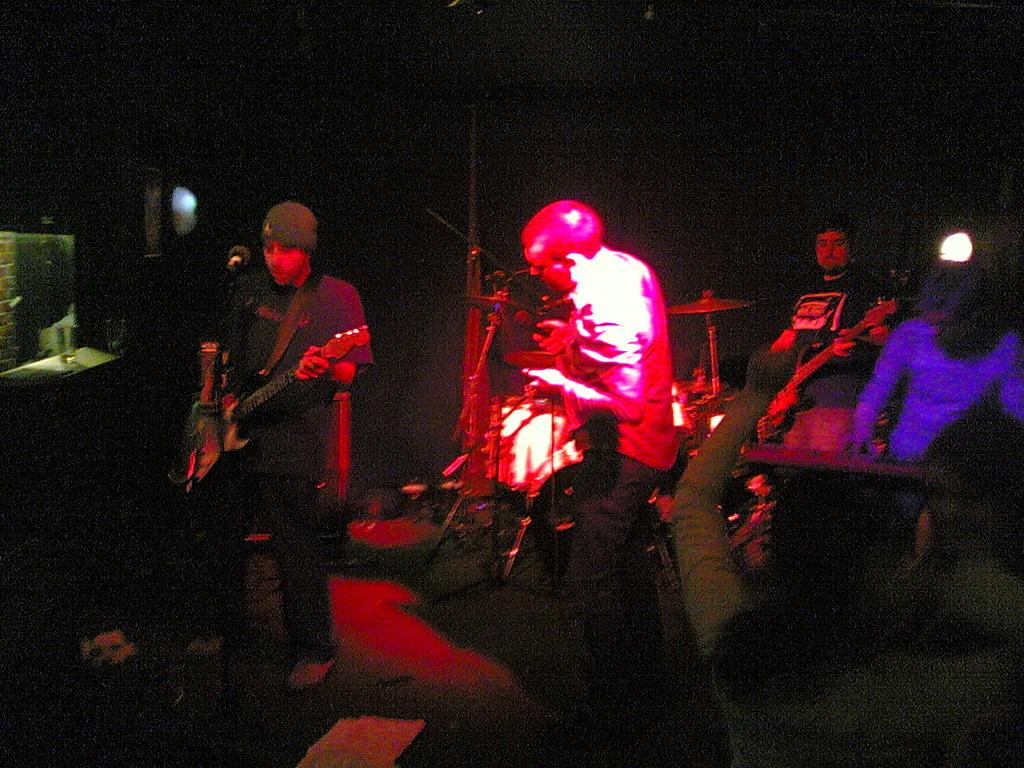How many people are in the image? There are people in the image, but the exact number is not specified. What are the people doing in the image? The people are standing and playing musical instruments. Can you describe the actions of the people in the image? The people are standing and using their hands to play musical instruments. What type of ball can be seen bouncing in the image? There is no ball present in the image; the people are playing musical instruments while standing. 